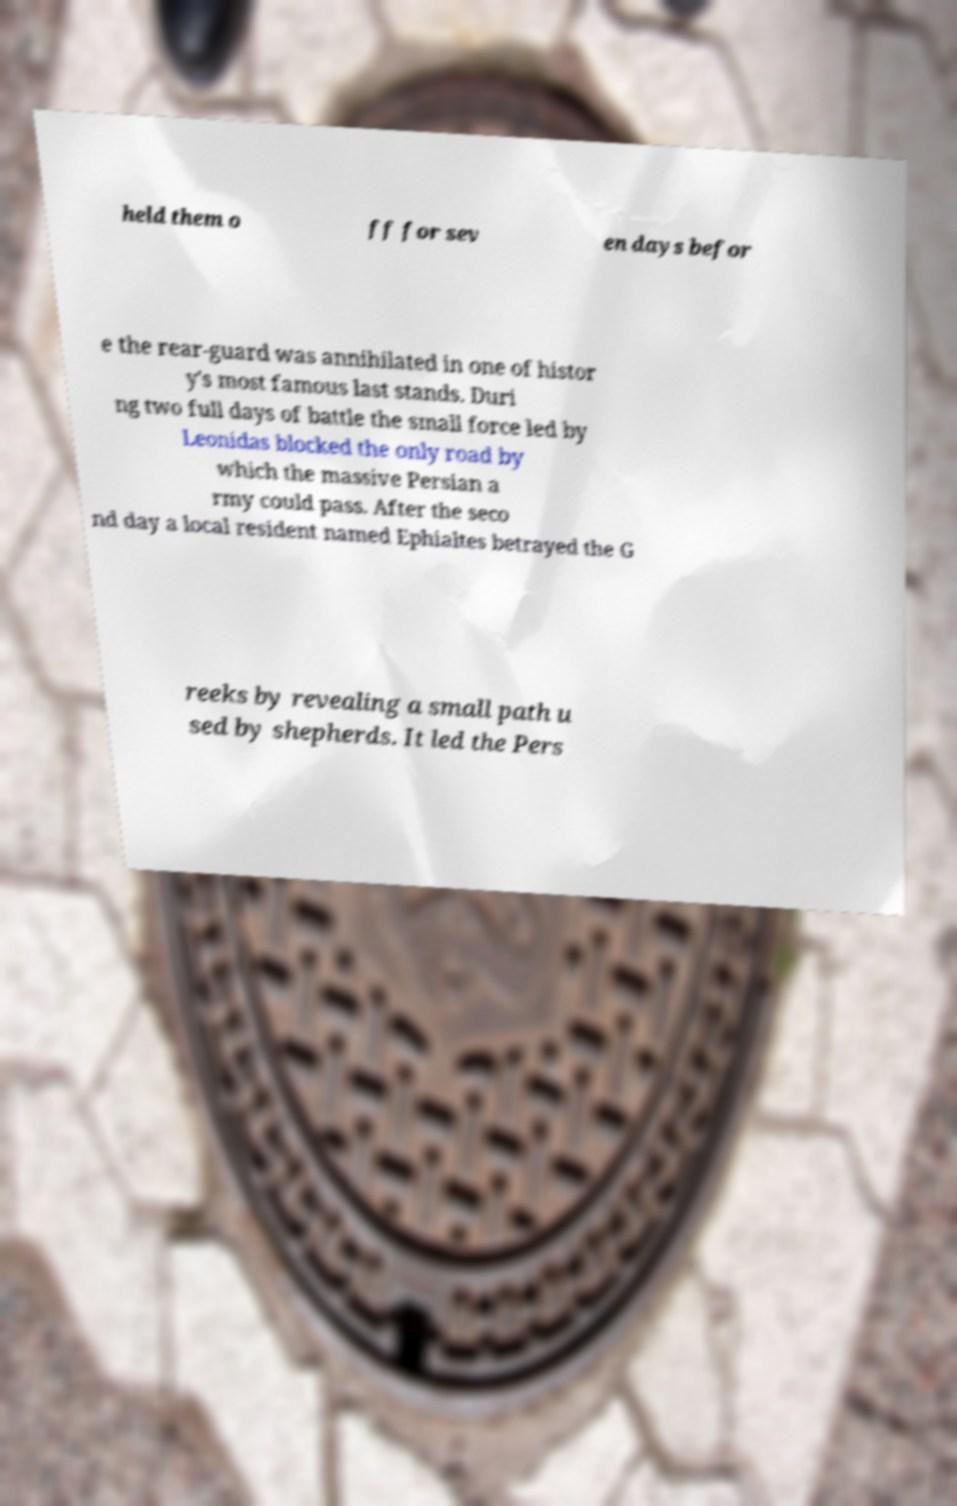Can you accurately transcribe the text from the provided image for me? held them o ff for sev en days befor e the rear-guard was annihilated in one of histor y's most famous last stands. Duri ng two full days of battle the small force led by Leonidas blocked the only road by which the massive Persian a rmy could pass. After the seco nd day a local resident named Ephialtes betrayed the G reeks by revealing a small path u sed by shepherds. It led the Pers 